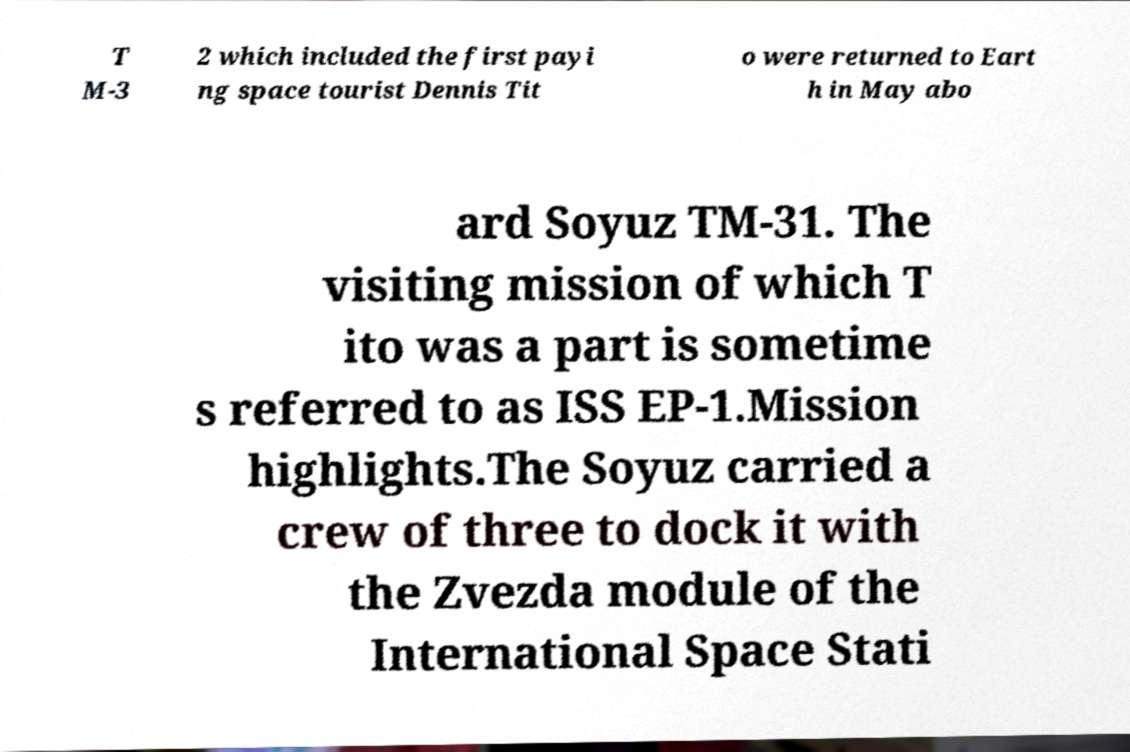Can you accurately transcribe the text from the provided image for me? T M-3 2 which included the first payi ng space tourist Dennis Tit o were returned to Eart h in May abo ard Soyuz TM-31. The visiting mission of which T ito was a part is sometime s referred to as ISS EP-1.Mission highlights.The Soyuz carried a crew of three to dock it with the Zvezda module of the International Space Stati 